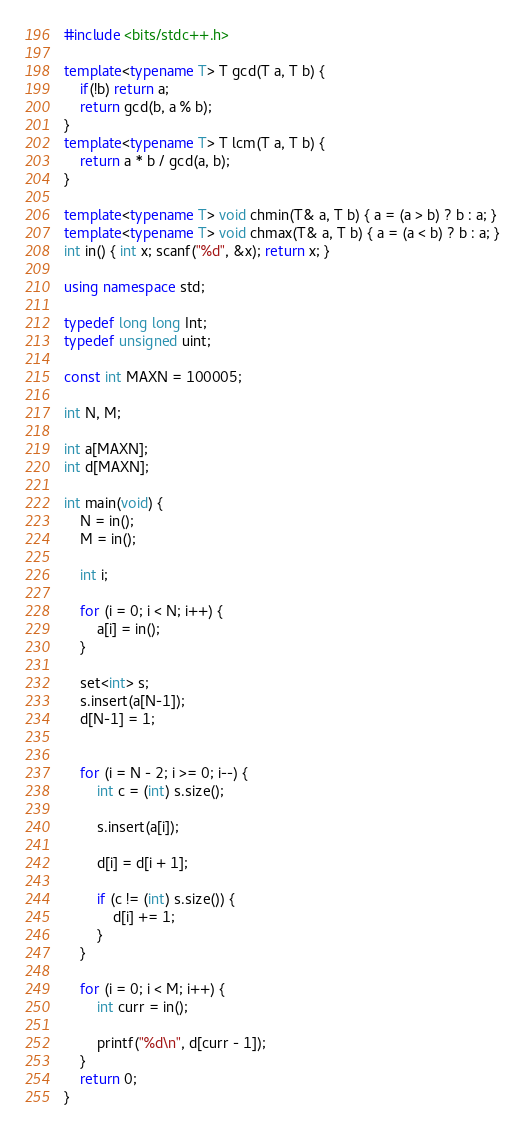Convert code to text. <code><loc_0><loc_0><loc_500><loc_500><_C++_>#include <bits/stdc++.h>

template<typename T> T gcd(T a, T b) {
    if(!b) return a;
    return gcd(b, a % b);
}
template<typename T> T lcm(T a, T b) {
    return a * b / gcd(a, b);
}

template<typename T> void chmin(T& a, T b) { a = (a > b) ? b : a; }
template<typename T> void chmax(T& a, T b) { a = (a < b) ? b : a; }
int in() { int x; scanf("%d", &x); return x; }

using namespace std;

typedef long long Int;
typedef unsigned uint;

const int MAXN = 100005;

int N, M;

int a[MAXN];
int d[MAXN];

int main(void) {
	N = in();
	M = in();

	int i;

	for (i = 0; i < N; i++) {
		a[i] = in();
	}

	set<int> s;
	s.insert(a[N-1]);
	d[N-1] = 1;


	for (i = N - 2; i >= 0; i--) {
		int c = (int) s.size();

		s.insert(a[i]);

		d[i] = d[i + 1];

		if (c != (int) s.size()) {
			d[i] += 1;
		}		
	}

	for (i = 0; i < M; i++) {
		int curr = in();

		printf("%d\n", d[curr - 1]);
	}
    return 0;
}
</code> 